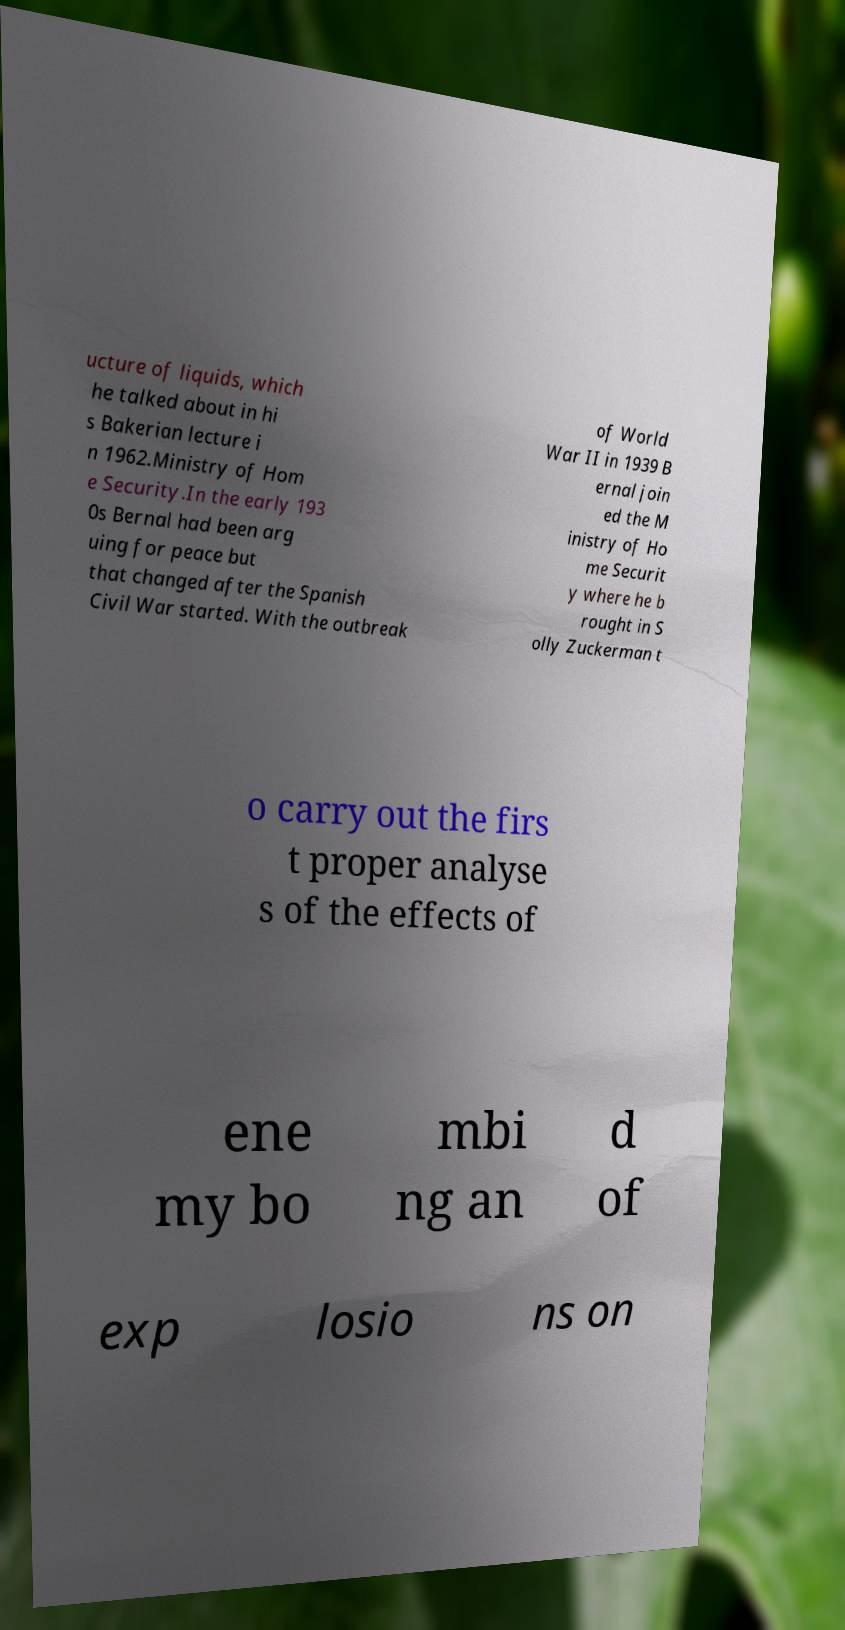Please read and relay the text visible in this image. What does it say? ucture of liquids, which he talked about in hi s Bakerian lecture i n 1962.Ministry of Hom e Security.In the early 193 0s Bernal had been arg uing for peace but that changed after the Spanish Civil War started. With the outbreak of World War II in 1939 B ernal join ed the M inistry of Ho me Securit y where he b rought in S olly Zuckerman t o carry out the firs t proper analyse s of the effects of ene my bo mbi ng an d of exp losio ns on 